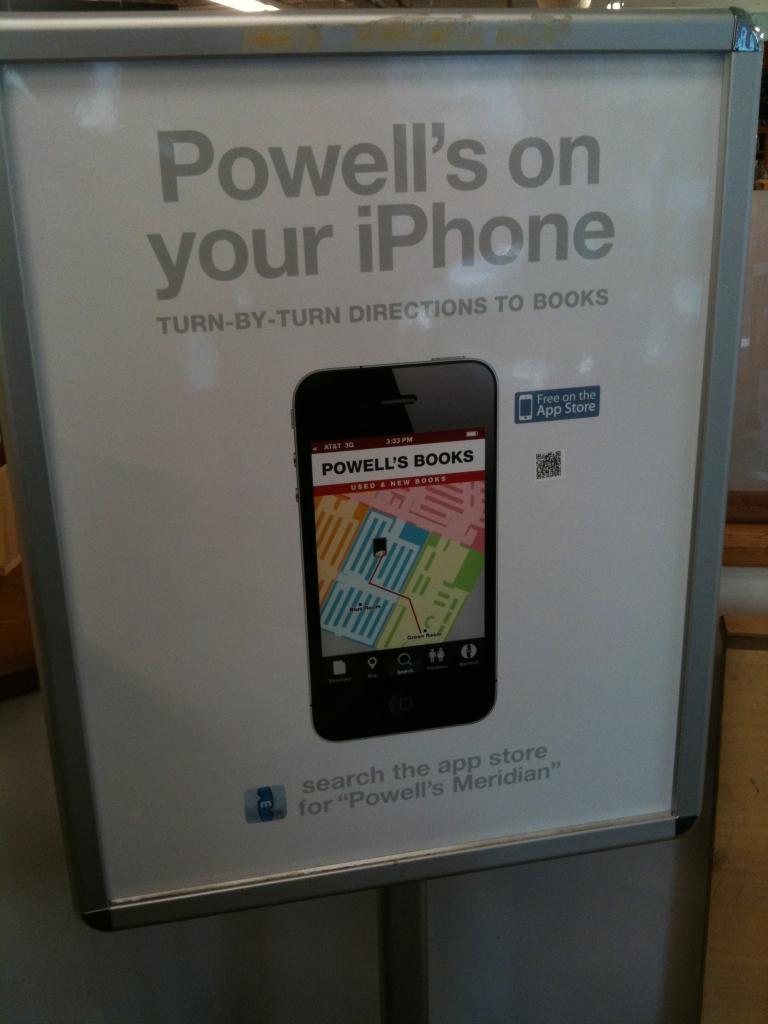What on your iphone?
Provide a succinct answer. Powell's. What type of directions to books?
Offer a terse response. Turn-by-turn. 